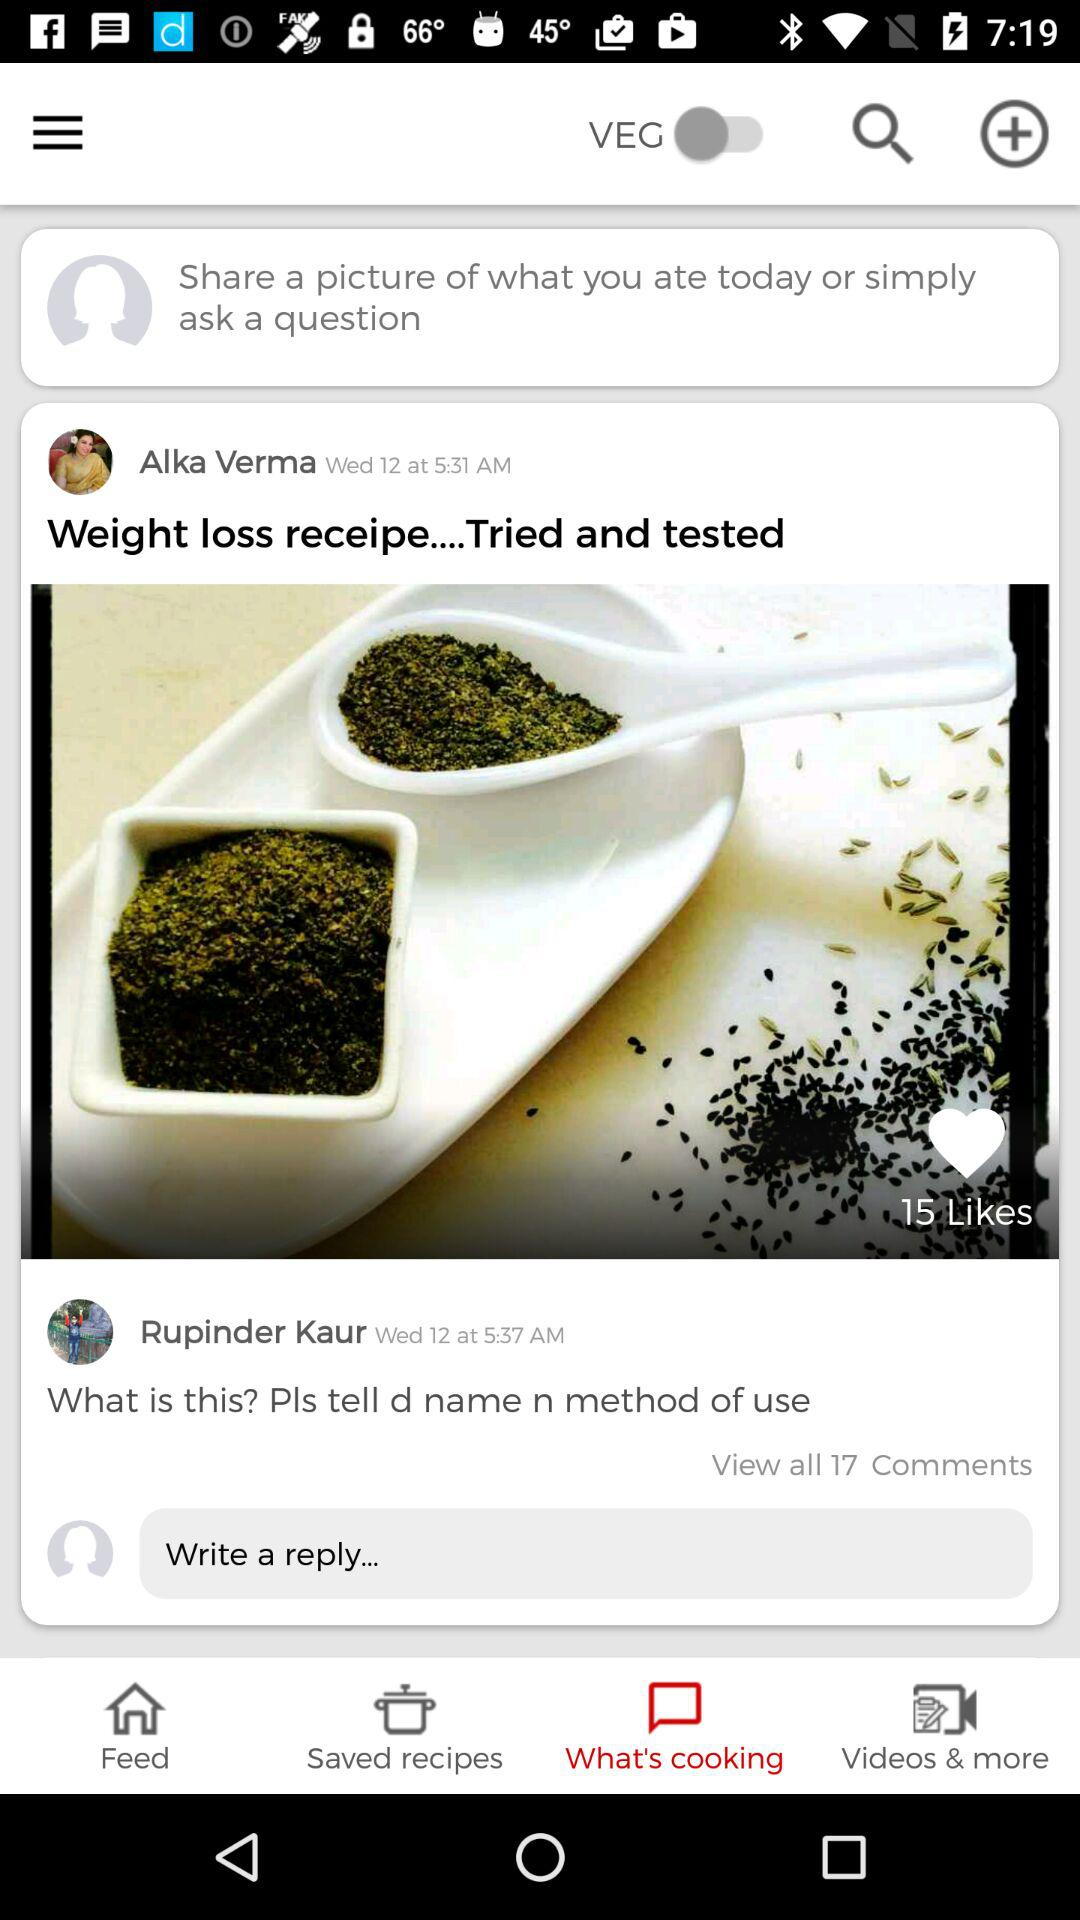How many people have liked the cumin seeds and cumin powder photo?
Answer the question using a single word or phrase. 15 